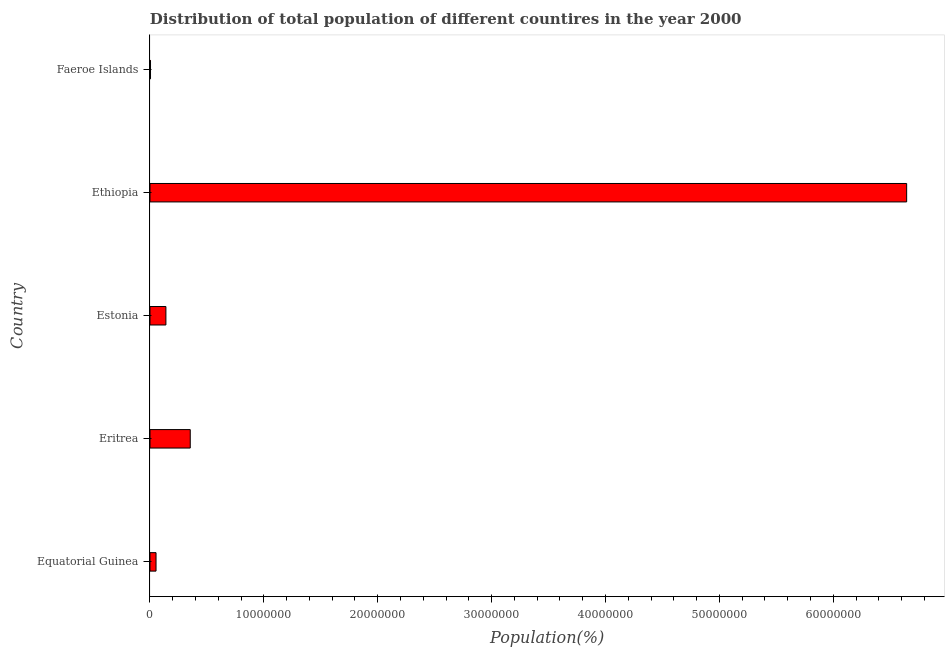Does the graph contain any zero values?
Your answer should be very brief. No. Does the graph contain grids?
Give a very brief answer. No. What is the title of the graph?
Your answer should be compact. Distribution of total population of different countires in the year 2000. What is the label or title of the X-axis?
Your response must be concise. Population(%). What is the population in Faeroe Islands?
Make the answer very short. 4.65e+04. Across all countries, what is the maximum population?
Give a very brief answer. 6.64e+07. Across all countries, what is the minimum population?
Your answer should be very brief. 4.65e+04. In which country was the population maximum?
Give a very brief answer. Ethiopia. In which country was the population minimum?
Provide a succinct answer. Faeroe Islands. What is the sum of the population?
Provide a succinct answer. 7.20e+07. What is the difference between the population in Eritrea and Ethiopia?
Offer a very short reply. -6.29e+07. What is the average population per country?
Offer a terse response. 1.44e+07. What is the median population?
Your answer should be very brief. 1.40e+06. What is the ratio of the population in Eritrea to that in Ethiopia?
Keep it short and to the point. 0.05. What is the difference between the highest and the second highest population?
Your response must be concise. 6.29e+07. Is the sum of the population in Estonia and Faeroe Islands greater than the maximum population across all countries?
Your answer should be very brief. No. What is the difference between the highest and the lowest population?
Offer a very short reply. 6.64e+07. In how many countries, is the population greater than the average population taken over all countries?
Your response must be concise. 1. How many bars are there?
Provide a succinct answer. 5. Are all the bars in the graph horizontal?
Give a very brief answer. Yes. How many countries are there in the graph?
Provide a succinct answer. 5. What is the Population(%) of Equatorial Guinea?
Your answer should be compact. 5.31e+05. What is the Population(%) in Eritrea?
Provide a succinct answer. 3.54e+06. What is the Population(%) in Estonia?
Your response must be concise. 1.40e+06. What is the Population(%) in Ethiopia?
Provide a short and direct response. 6.64e+07. What is the Population(%) of Faeroe Islands?
Give a very brief answer. 4.65e+04. What is the difference between the Population(%) in Equatorial Guinea and Eritrea?
Provide a succinct answer. -3.00e+06. What is the difference between the Population(%) in Equatorial Guinea and Estonia?
Your answer should be very brief. -8.66e+05. What is the difference between the Population(%) in Equatorial Guinea and Ethiopia?
Your answer should be very brief. -6.59e+07. What is the difference between the Population(%) in Equatorial Guinea and Faeroe Islands?
Ensure brevity in your answer.  4.84e+05. What is the difference between the Population(%) in Eritrea and Estonia?
Offer a very short reply. 2.14e+06. What is the difference between the Population(%) in Eritrea and Ethiopia?
Ensure brevity in your answer.  -6.29e+07. What is the difference between the Population(%) in Eritrea and Faeroe Islands?
Offer a very short reply. 3.49e+06. What is the difference between the Population(%) in Estonia and Ethiopia?
Make the answer very short. -6.50e+07. What is the difference between the Population(%) in Estonia and Faeroe Islands?
Give a very brief answer. 1.35e+06. What is the difference between the Population(%) in Ethiopia and Faeroe Islands?
Make the answer very short. 6.64e+07. What is the ratio of the Population(%) in Equatorial Guinea to that in Eritrea?
Make the answer very short. 0.15. What is the ratio of the Population(%) in Equatorial Guinea to that in Estonia?
Offer a very short reply. 0.38. What is the ratio of the Population(%) in Equatorial Guinea to that in Ethiopia?
Give a very brief answer. 0.01. What is the ratio of the Population(%) in Equatorial Guinea to that in Faeroe Islands?
Your answer should be very brief. 11.42. What is the ratio of the Population(%) in Eritrea to that in Estonia?
Your answer should be very brief. 2.53. What is the ratio of the Population(%) in Eritrea to that in Ethiopia?
Make the answer very short. 0.05. What is the ratio of the Population(%) in Eritrea to that in Faeroe Islands?
Provide a succinct answer. 76.04. What is the ratio of the Population(%) in Estonia to that in Ethiopia?
Provide a succinct answer. 0.02. What is the ratio of the Population(%) in Estonia to that in Faeroe Islands?
Offer a terse response. 30.05. What is the ratio of the Population(%) in Ethiopia to that in Faeroe Islands?
Provide a short and direct response. 1429.17. 